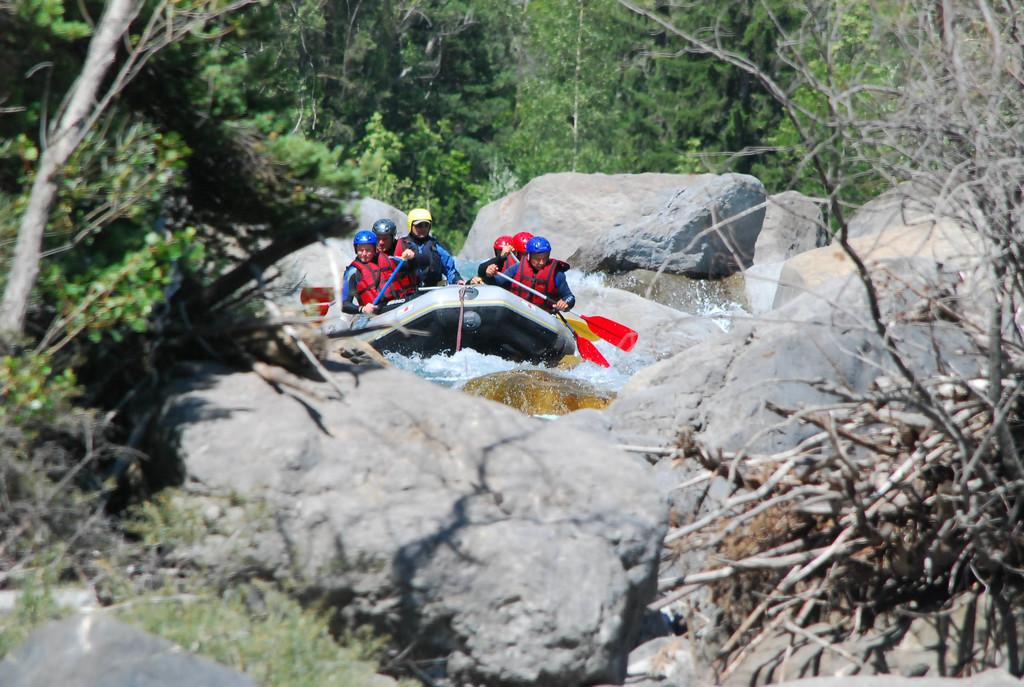Who is present in the image? There is a group of friends in the image. What activity are the friends engaged in? The friends are doing boating in the image. What type of landscape can be seen in the background? There are stone rock mountains and many trees in the image. What type of cherries can be seen floating in the water near the boat? There are no cherries present in the image; the friends are boating in a body of water with no visible fruit. 